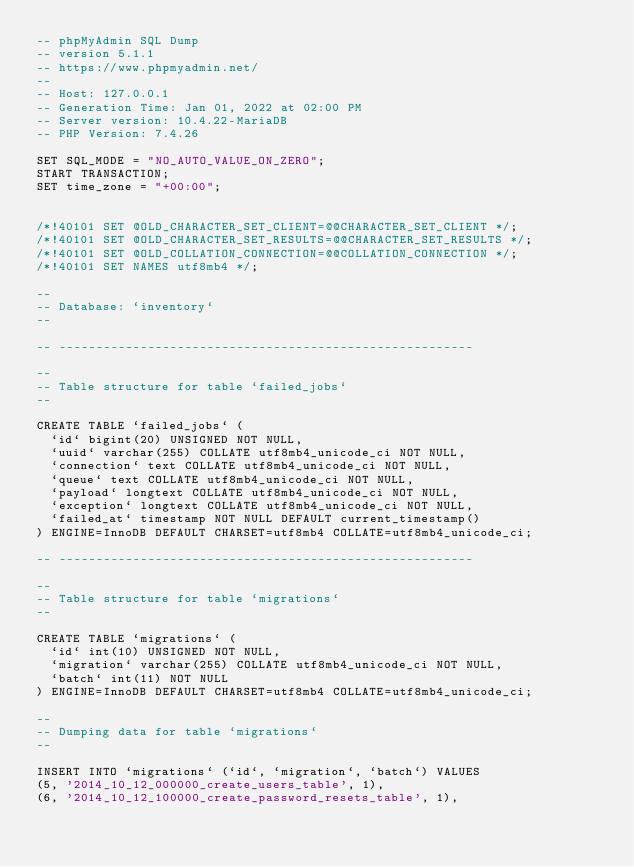<code> <loc_0><loc_0><loc_500><loc_500><_SQL_>-- phpMyAdmin SQL Dump
-- version 5.1.1
-- https://www.phpmyadmin.net/
--
-- Host: 127.0.0.1
-- Generation Time: Jan 01, 2022 at 02:00 PM
-- Server version: 10.4.22-MariaDB
-- PHP Version: 7.4.26

SET SQL_MODE = "NO_AUTO_VALUE_ON_ZERO";
START TRANSACTION;
SET time_zone = "+00:00";


/*!40101 SET @OLD_CHARACTER_SET_CLIENT=@@CHARACTER_SET_CLIENT */;
/*!40101 SET @OLD_CHARACTER_SET_RESULTS=@@CHARACTER_SET_RESULTS */;
/*!40101 SET @OLD_COLLATION_CONNECTION=@@COLLATION_CONNECTION */;
/*!40101 SET NAMES utf8mb4 */;

--
-- Database: `inventory`
--

-- --------------------------------------------------------

--
-- Table structure for table `failed_jobs`
--

CREATE TABLE `failed_jobs` (
  `id` bigint(20) UNSIGNED NOT NULL,
  `uuid` varchar(255) COLLATE utf8mb4_unicode_ci NOT NULL,
  `connection` text COLLATE utf8mb4_unicode_ci NOT NULL,
  `queue` text COLLATE utf8mb4_unicode_ci NOT NULL,
  `payload` longtext COLLATE utf8mb4_unicode_ci NOT NULL,
  `exception` longtext COLLATE utf8mb4_unicode_ci NOT NULL,
  `failed_at` timestamp NOT NULL DEFAULT current_timestamp()
) ENGINE=InnoDB DEFAULT CHARSET=utf8mb4 COLLATE=utf8mb4_unicode_ci;

-- --------------------------------------------------------

--
-- Table structure for table `migrations`
--

CREATE TABLE `migrations` (
  `id` int(10) UNSIGNED NOT NULL,
  `migration` varchar(255) COLLATE utf8mb4_unicode_ci NOT NULL,
  `batch` int(11) NOT NULL
) ENGINE=InnoDB DEFAULT CHARSET=utf8mb4 COLLATE=utf8mb4_unicode_ci;

--
-- Dumping data for table `migrations`
--

INSERT INTO `migrations` (`id`, `migration`, `batch`) VALUES
(5, '2014_10_12_000000_create_users_table', 1),
(6, '2014_10_12_100000_create_password_resets_table', 1),</code> 